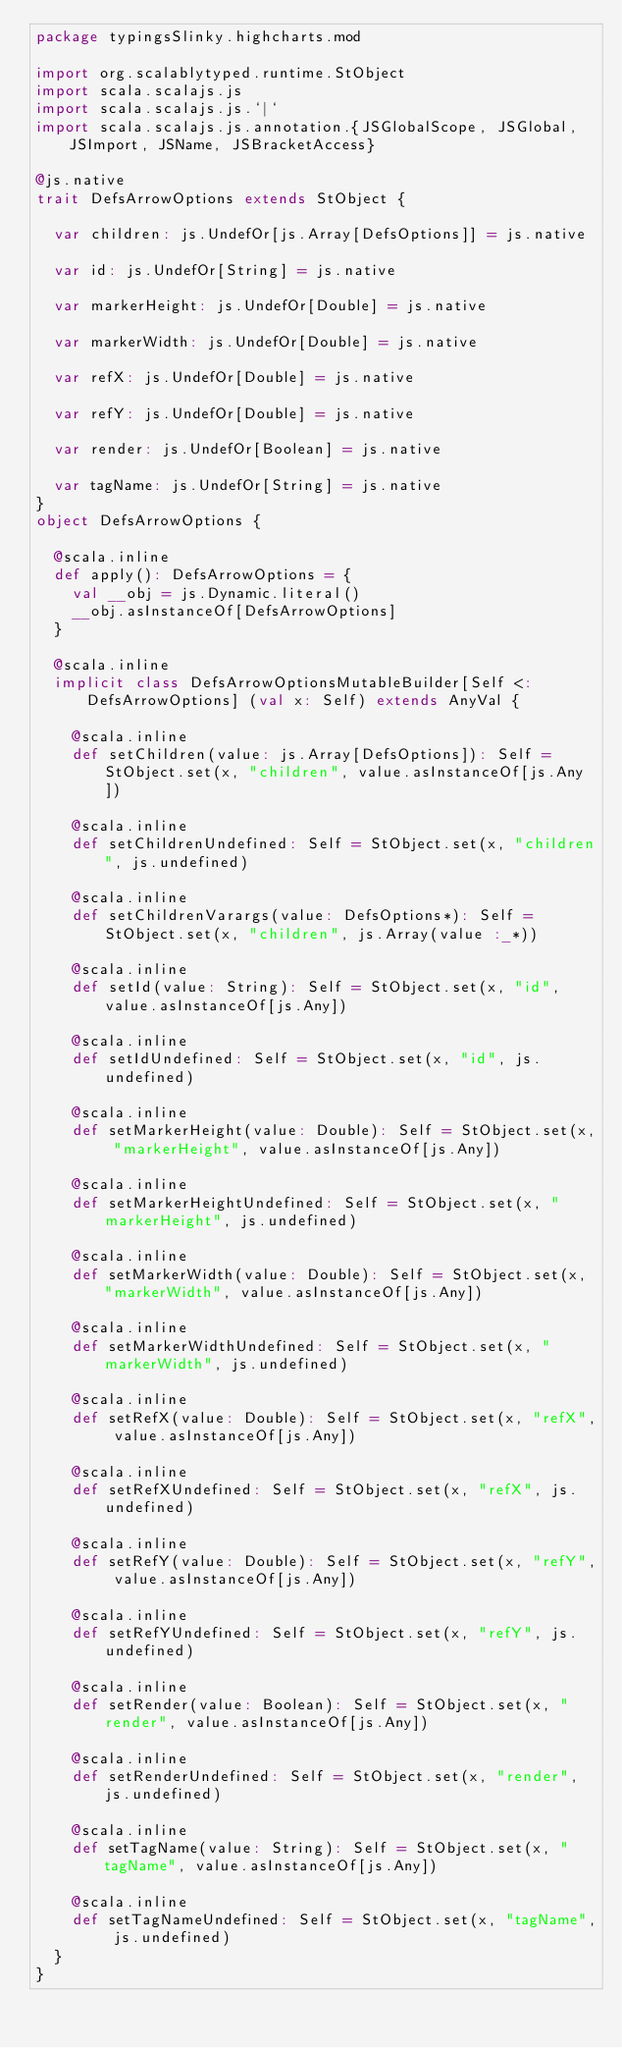<code> <loc_0><loc_0><loc_500><loc_500><_Scala_>package typingsSlinky.highcharts.mod

import org.scalablytyped.runtime.StObject
import scala.scalajs.js
import scala.scalajs.js.`|`
import scala.scalajs.js.annotation.{JSGlobalScope, JSGlobal, JSImport, JSName, JSBracketAccess}

@js.native
trait DefsArrowOptions extends StObject {
  
  var children: js.UndefOr[js.Array[DefsOptions]] = js.native
  
  var id: js.UndefOr[String] = js.native
  
  var markerHeight: js.UndefOr[Double] = js.native
  
  var markerWidth: js.UndefOr[Double] = js.native
  
  var refX: js.UndefOr[Double] = js.native
  
  var refY: js.UndefOr[Double] = js.native
  
  var render: js.UndefOr[Boolean] = js.native
  
  var tagName: js.UndefOr[String] = js.native
}
object DefsArrowOptions {
  
  @scala.inline
  def apply(): DefsArrowOptions = {
    val __obj = js.Dynamic.literal()
    __obj.asInstanceOf[DefsArrowOptions]
  }
  
  @scala.inline
  implicit class DefsArrowOptionsMutableBuilder[Self <: DefsArrowOptions] (val x: Self) extends AnyVal {
    
    @scala.inline
    def setChildren(value: js.Array[DefsOptions]): Self = StObject.set(x, "children", value.asInstanceOf[js.Any])
    
    @scala.inline
    def setChildrenUndefined: Self = StObject.set(x, "children", js.undefined)
    
    @scala.inline
    def setChildrenVarargs(value: DefsOptions*): Self = StObject.set(x, "children", js.Array(value :_*))
    
    @scala.inline
    def setId(value: String): Self = StObject.set(x, "id", value.asInstanceOf[js.Any])
    
    @scala.inline
    def setIdUndefined: Self = StObject.set(x, "id", js.undefined)
    
    @scala.inline
    def setMarkerHeight(value: Double): Self = StObject.set(x, "markerHeight", value.asInstanceOf[js.Any])
    
    @scala.inline
    def setMarkerHeightUndefined: Self = StObject.set(x, "markerHeight", js.undefined)
    
    @scala.inline
    def setMarkerWidth(value: Double): Self = StObject.set(x, "markerWidth", value.asInstanceOf[js.Any])
    
    @scala.inline
    def setMarkerWidthUndefined: Self = StObject.set(x, "markerWidth", js.undefined)
    
    @scala.inline
    def setRefX(value: Double): Self = StObject.set(x, "refX", value.asInstanceOf[js.Any])
    
    @scala.inline
    def setRefXUndefined: Self = StObject.set(x, "refX", js.undefined)
    
    @scala.inline
    def setRefY(value: Double): Self = StObject.set(x, "refY", value.asInstanceOf[js.Any])
    
    @scala.inline
    def setRefYUndefined: Self = StObject.set(x, "refY", js.undefined)
    
    @scala.inline
    def setRender(value: Boolean): Self = StObject.set(x, "render", value.asInstanceOf[js.Any])
    
    @scala.inline
    def setRenderUndefined: Self = StObject.set(x, "render", js.undefined)
    
    @scala.inline
    def setTagName(value: String): Self = StObject.set(x, "tagName", value.asInstanceOf[js.Any])
    
    @scala.inline
    def setTagNameUndefined: Self = StObject.set(x, "tagName", js.undefined)
  }
}
</code> 